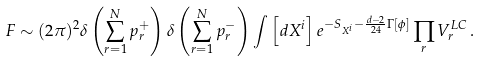<formula> <loc_0><loc_0><loc_500><loc_500>F \sim ( 2 \pi ) ^ { 2 } \delta \left ( \sum _ { r = 1 } ^ { N } p ^ { + } _ { r } \right ) \delta \left ( \sum _ { r = 1 } ^ { N } p ^ { - } _ { r } \right ) \int \left [ d X ^ { i } \right ] e ^ { - S _ { X ^ { i } } - \frac { d - 2 } { 2 4 } \Gamma [ \phi ] } \prod _ { r } V _ { r } ^ { L C } \, .</formula> 